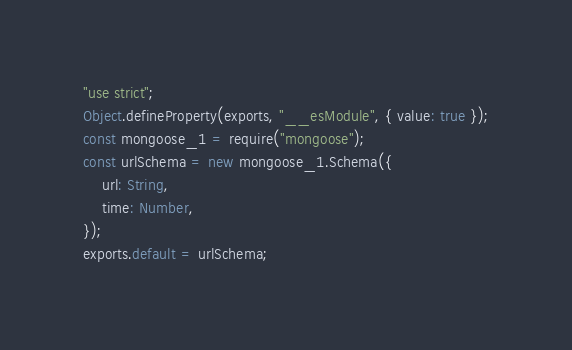Convert code to text. <code><loc_0><loc_0><loc_500><loc_500><_JavaScript_>"use strict";
Object.defineProperty(exports, "__esModule", { value: true });
const mongoose_1 = require("mongoose");
const urlSchema = new mongoose_1.Schema({
    url: String,
    time: Number,
});
exports.default = urlSchema;
</code> 